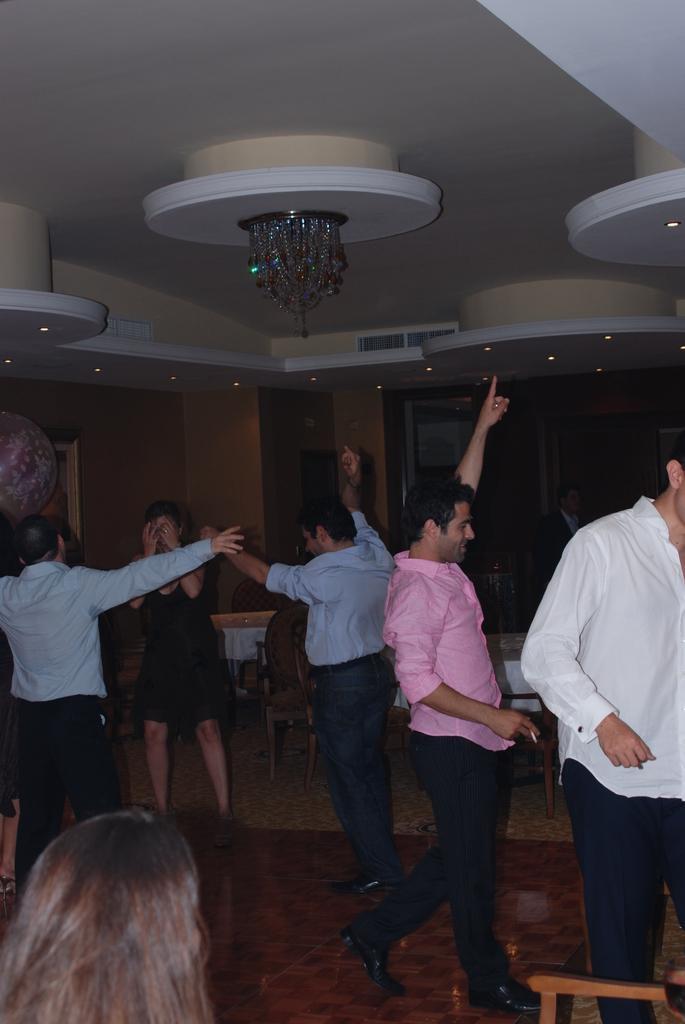Please provide a concise description of this image. In this image, we can see people performing dance and there are some chairs and tables and there is a wall. At the top, there is ceiling and we can see some lights. 